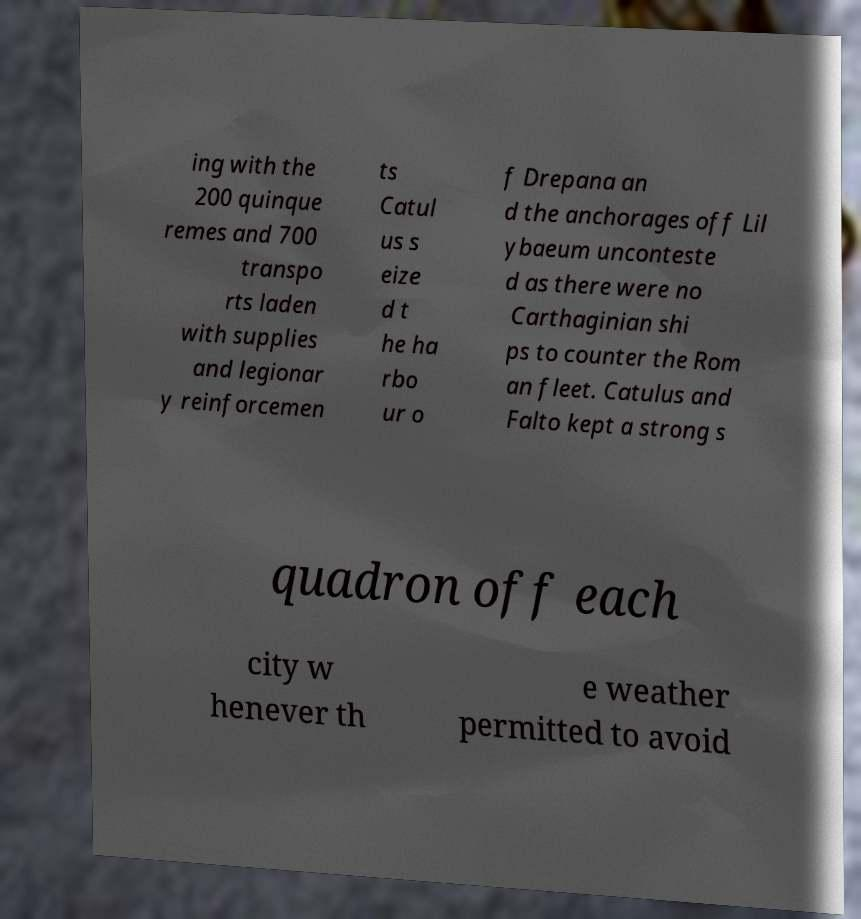Can you read and provide the text displayed in the image?This photo seems to have some interesting text. Can you extract and type it out for me? ing with the 200 quinque remes and 700 transpo rts laden with supplies and legionar y reinforcemen ts Catul us s eize d t he ha rbo ur o f Drepana an d the anchorages off Lil ybaeum unconteste d as there were no Carthaginian shi ps to counter the Rom an fleet. Catulus and Falto kept a strong s quadron off each city w henever th e weather permitted to avoid 